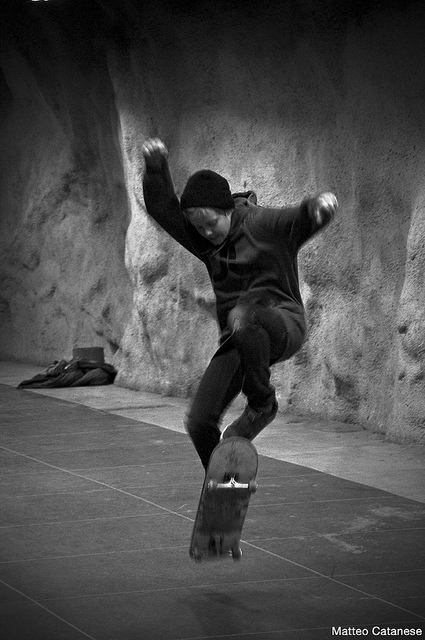Please transcribe the text information in this image. Matteo CANTANESE 